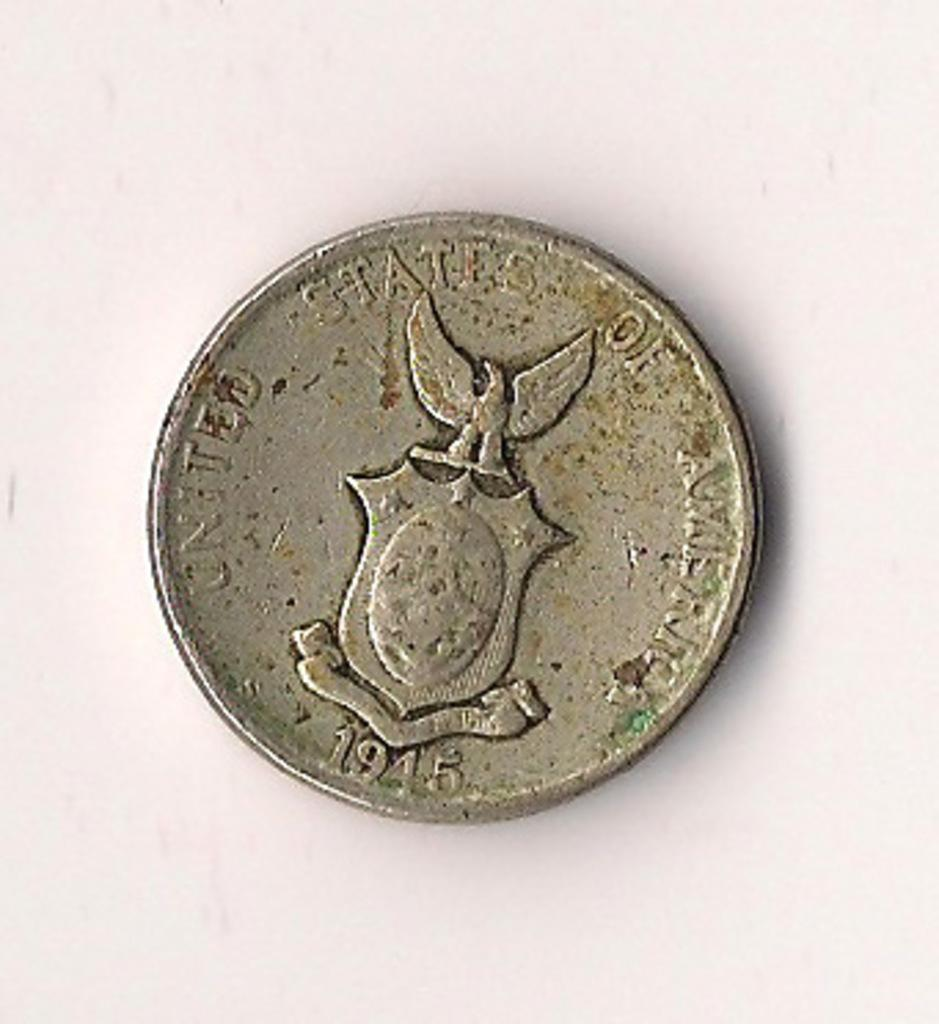<image>
Write a terse but informative summary of the picture. The United States issued limited edition World War 2 victory coins. 